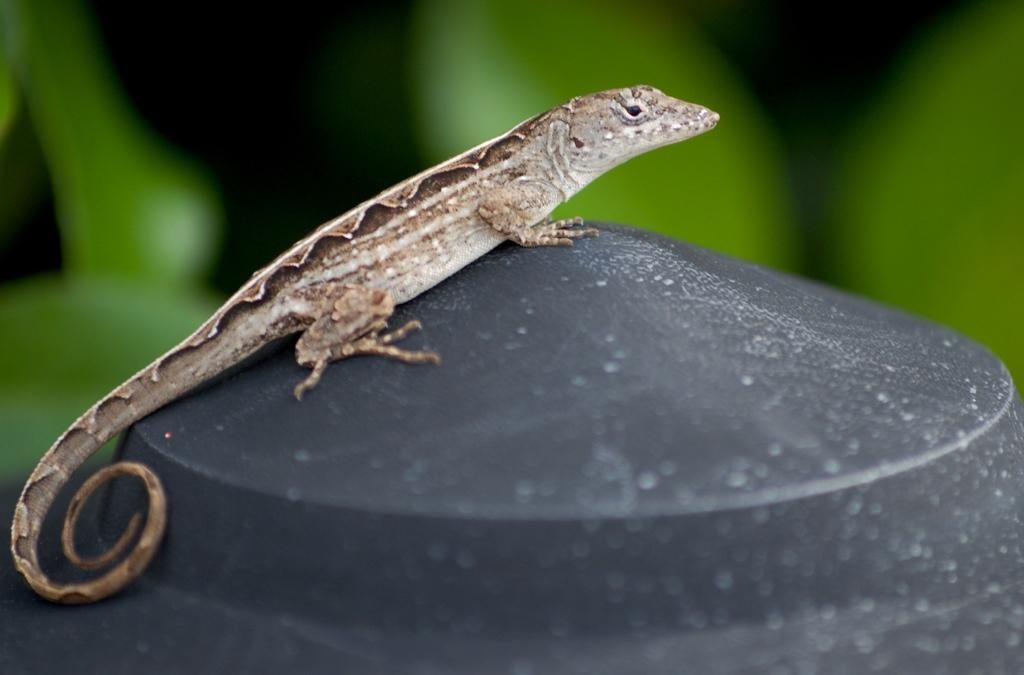What type of animal is in the picture? There is a reptile in the picture. What is the reptile resting on? The reptile is on a black surface. Can you describe the background of the image? The background of the image is blurred, and the background color is green. What type of paint is being used to create the reptile's markings in the image? There is no information about paint or markings in the image; it simply shows a reptile on a black surface with a blurred, green background. 